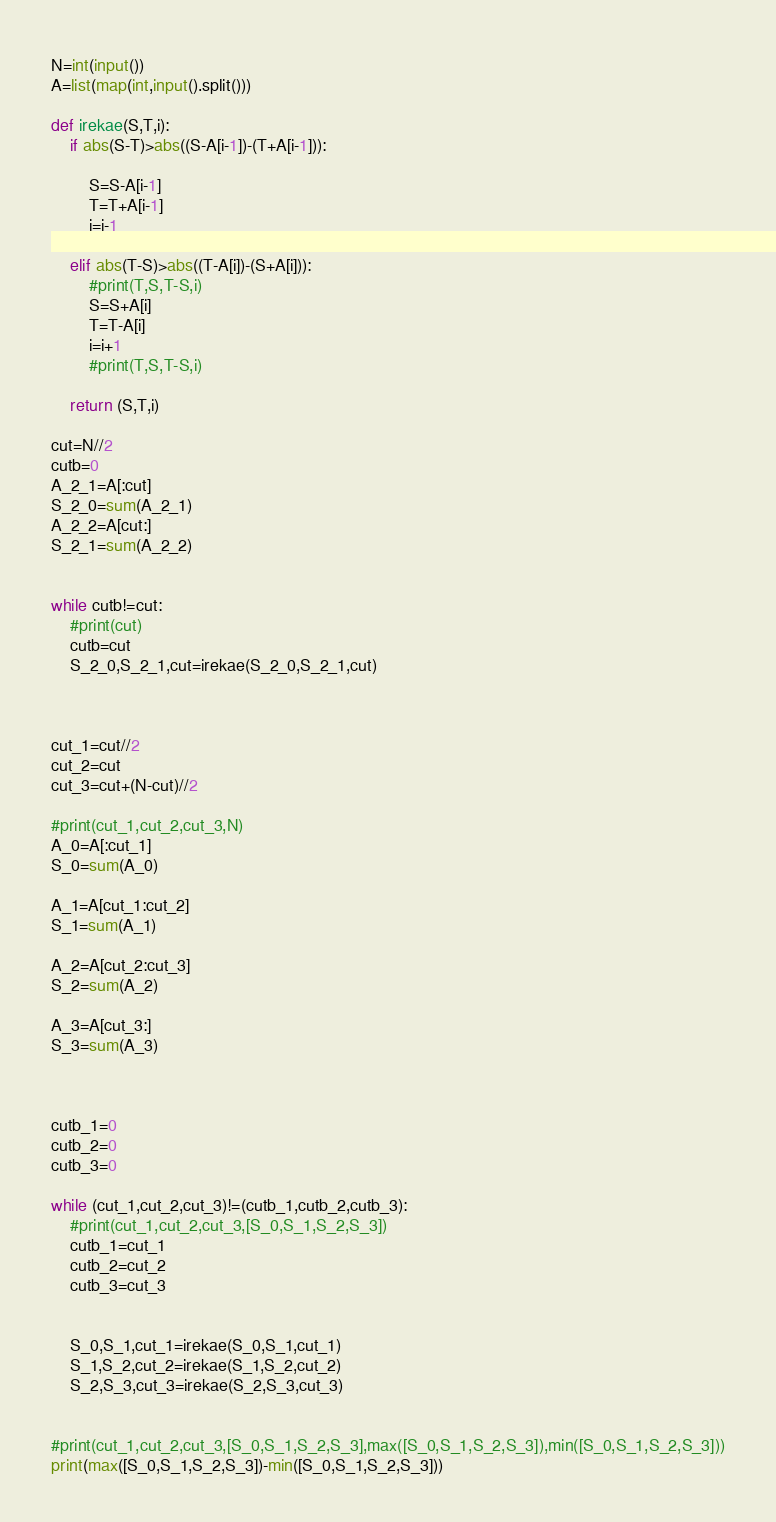<code> <loc_0><loc_0><loc_500><loc_500><_Python_>N=int(input())
A=list(map(int,input().split()))

def irekae(S,T,i):
    if abs(S-T)>abs((S-A[i-1])-(T+A[i-1])):
        
        S=S-A[i-1]
        T=T+A[i-1]
        i=i-1
        
    elif abs(T-S)>abs((T-A[i])-(S+A[i])):
        #print(T,S,T-S,i)
        S=S+A[i]
        T=T-A[i]
        i=i+1
        #print(T,S,T-S,i)

    return (S,T,i)

cut=N//2
cutb=0
A_2_1=A[:cut]
S_2_0=sum(A_2_1)
A_2_2=A[cut:]
S_2_1=sum(A_2_2)


while cutb!=cut:
    #print(cut)
    cutb=cut
    S_2_0,S_2_1,cut=irekae(S_2_0,S_2_1,cut)



cut_1=cut//2
cut_2=cut
cut_3=cut+(N-cut)//2

#print(cut_1,cut_2,cut_3,N)
A_0=A[:cut_1]
S_0=sum(A_0)

A_1=A[cut_1:cut_2]
S_1=sum(A_1)

A_2=A[cut_2:cut_3]
S_2=sum(A_2)

A_3=A[cut_3:]
S_3=sum(A_3)



cutb_1=0
cutb_2=0
cutb_3=0

while (cut_1,cut_2,cut_3)!=(cutb_1,cutb_2,cutb_3):
    #print(cut_1,cut_2,cut_3,[S_0,S_1,S_2,S_3])
    cutb_1=cut_1
    cutb_2=cut_2
    cutb_3=cut_3
    

    S_0,S_1,cut_1=irekae(S_0,S_1,cut_1)
    S_1,S_2,cut_2=irekae(S_1,S_2,cut_2)
    S_2,S_3,cut_3=irekae(S_2,S_3,cut_3)


#print(cut_1,cut_2,cut_3,[S_0,S_1,S_2,S_3],max([S_0,S_1,S_2,S_3]),min([S_0,S_1,S_2,S_3]))
print(max([S_0,S_1,S_2,S_3])-min([S_0,S_1,S_2,S_3]))
</code> 